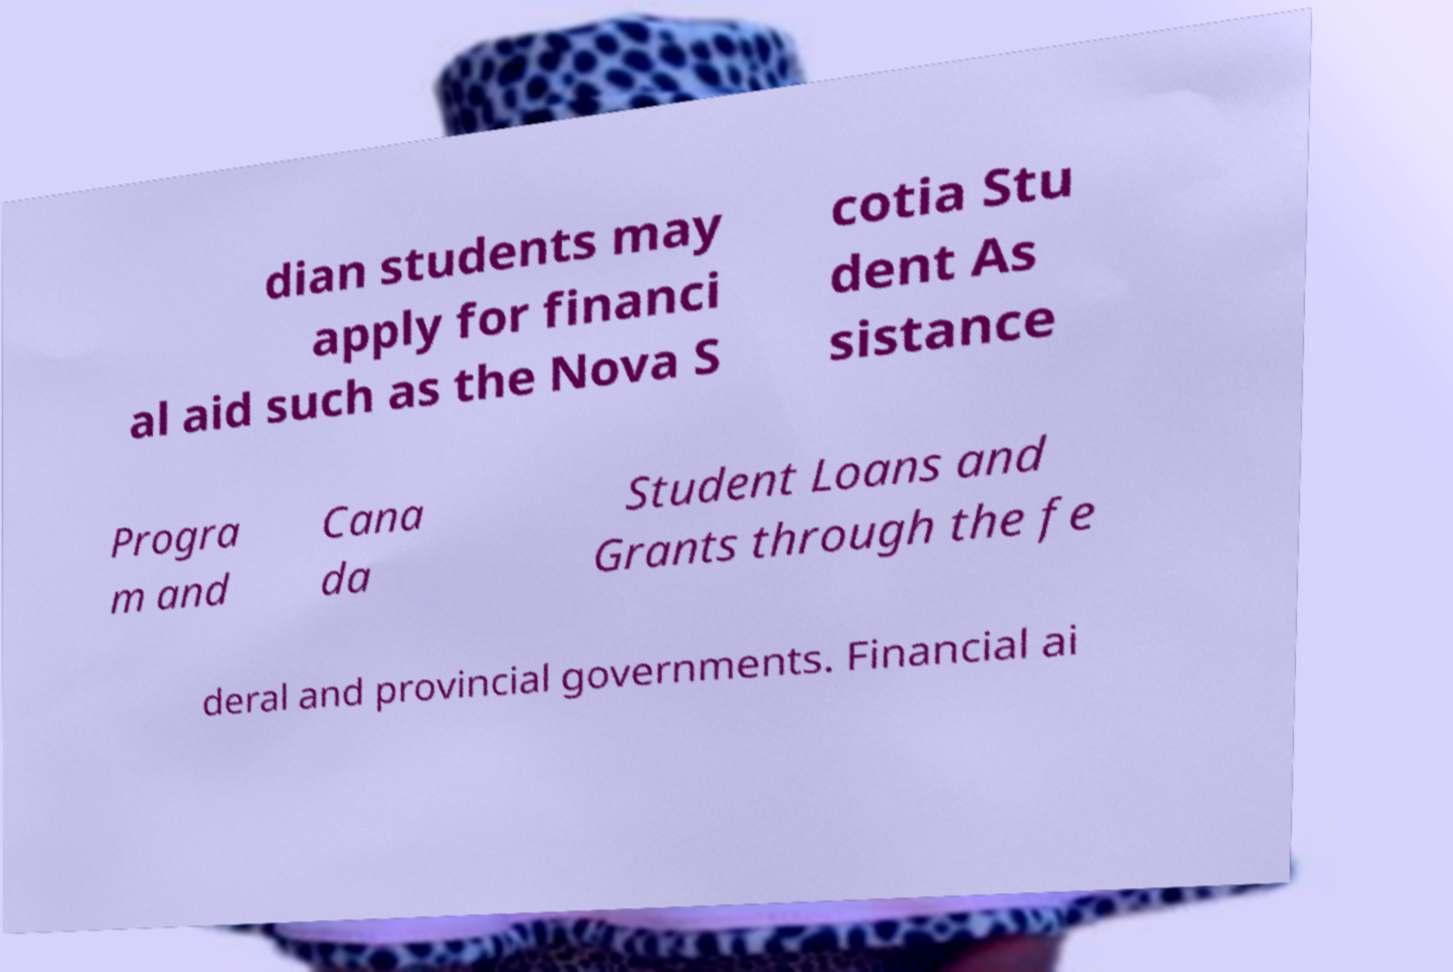Please read and relay the text visible in this image. What does it say? dian students may apply for financi al aid such as the Nova S cotia Stu dent As sistance Progra m and Cana da Student Loans and Grants through the fe deral and provincial governments. Financial ai 